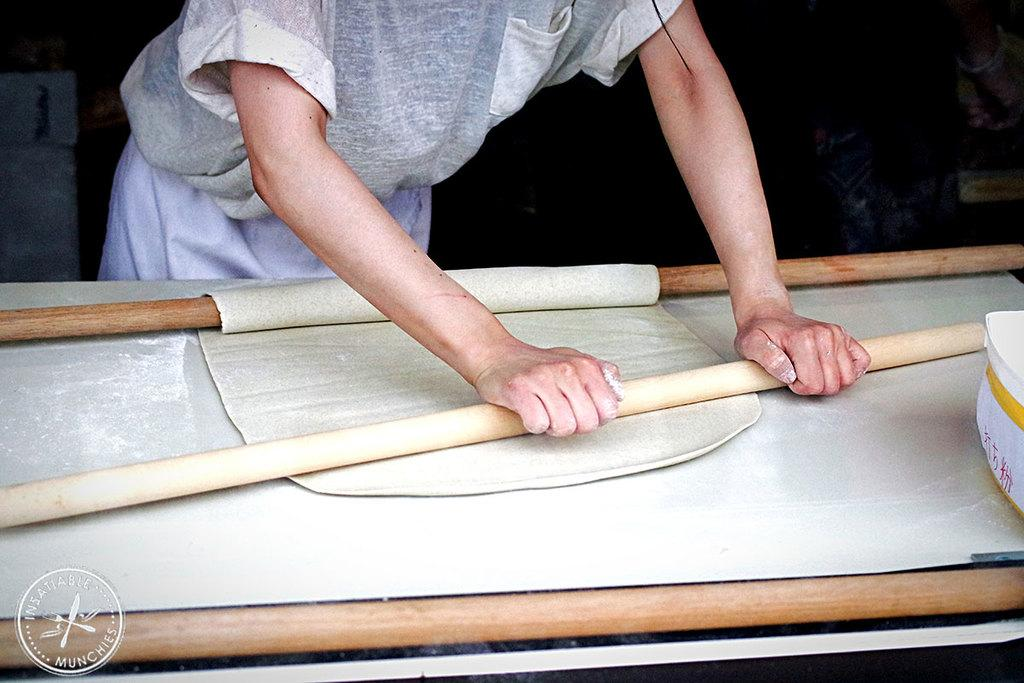What is the main subject of the image? There is a man standing in the image. What is in front of the man? There is a table in front of the man. What is the person holding in the image? The person is holding dough with a rolling pin. What type of rub can be seen on the scarecrow in the image? There is no scarecrow present in the image, and therefore no rub can be observed. 